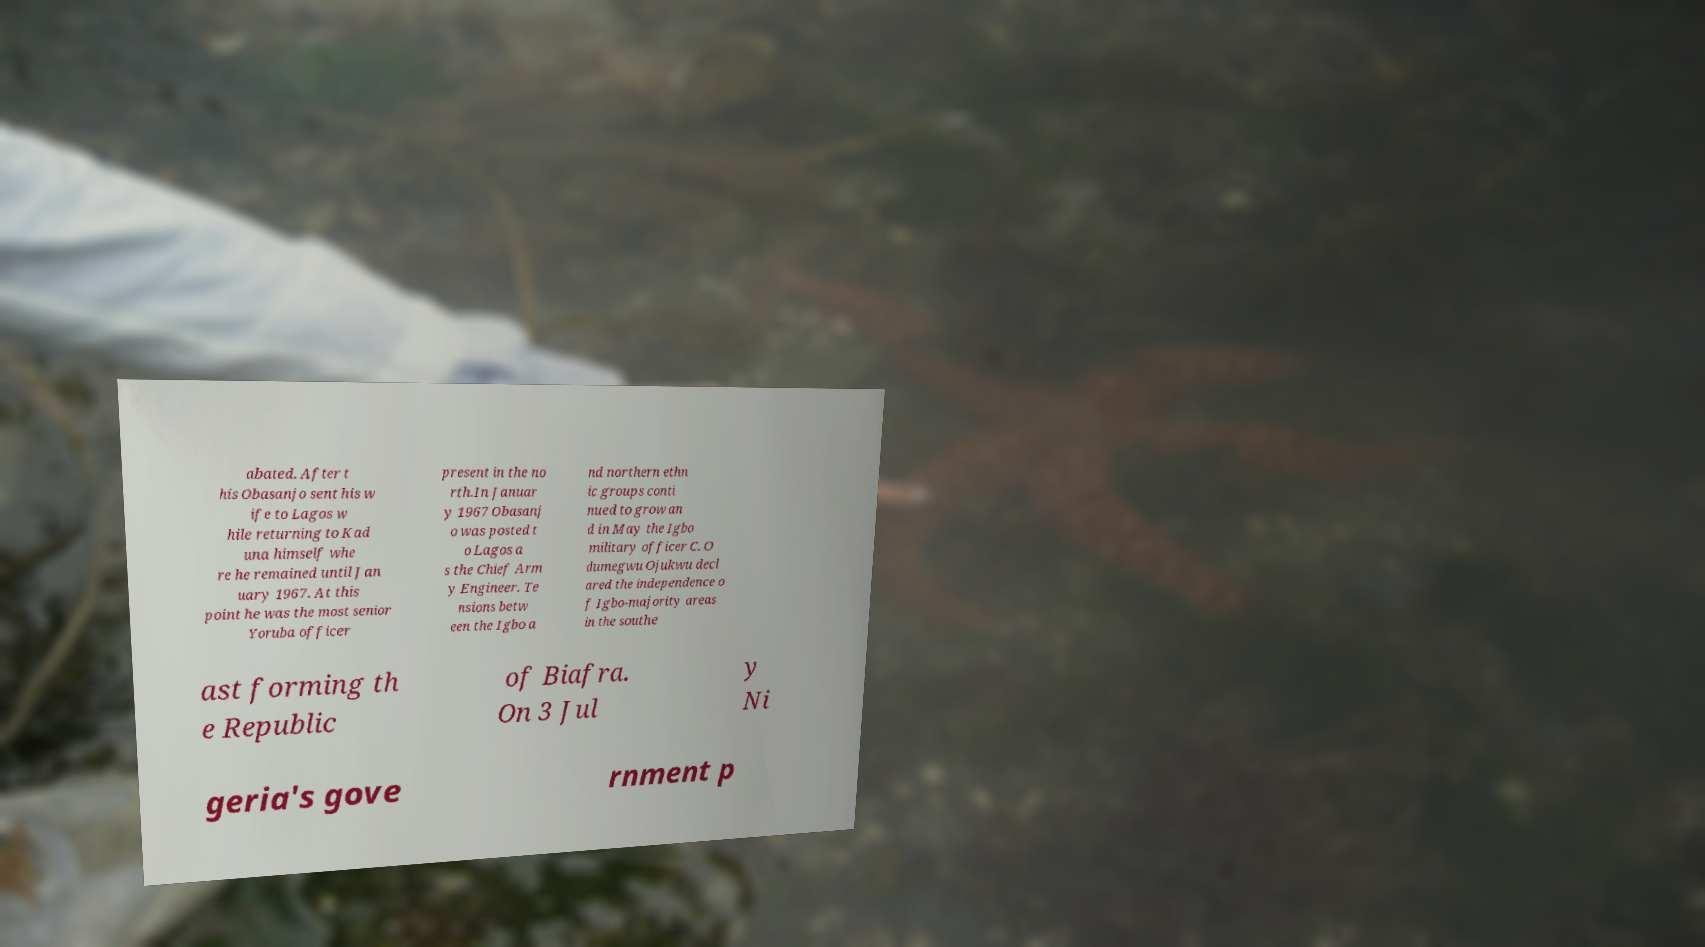What messages or text are displayed in this image? I need them in a readable, typed format. abated. After t his Obasanjo sent his w ife to Lagos w hile returning to Kad una himself whe re he remained until Jan uary 1967. At this point he was the most senior Yoruba officer present in the no rth.In Januar y 1967 Obasanj o was posted t o Lagos a s the Chief Arm y Engineer. Te nsions betw een the Igbo a nd northern ethn ic groups conti nued to grow an d in May the Igbo military officer C. O dumegwu Ojukwu decl ared the independence o f Igbo-majority areas in the southe ast forming th e Republic of Biafra. On 3 Jul y Ni geria's gove rnment p 